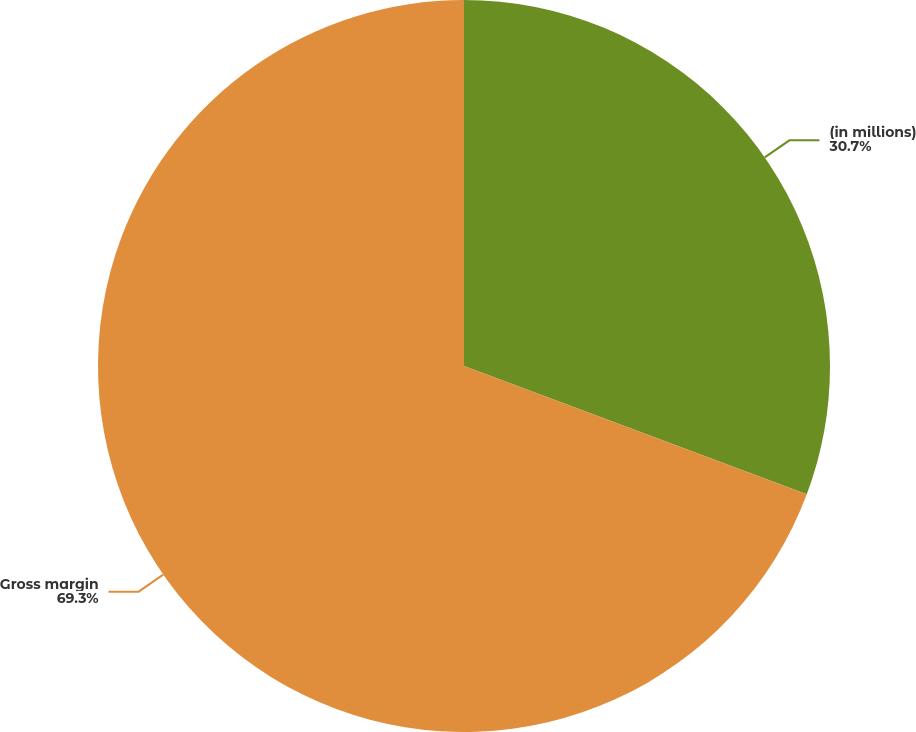<chart> <loc_0><loc_0><loc_500><loc_500><pie_chart><fcel>(in millions)<fcel>Gross margin<nl><fcel>30.7%<fcel>69.3%<nl></chart> 